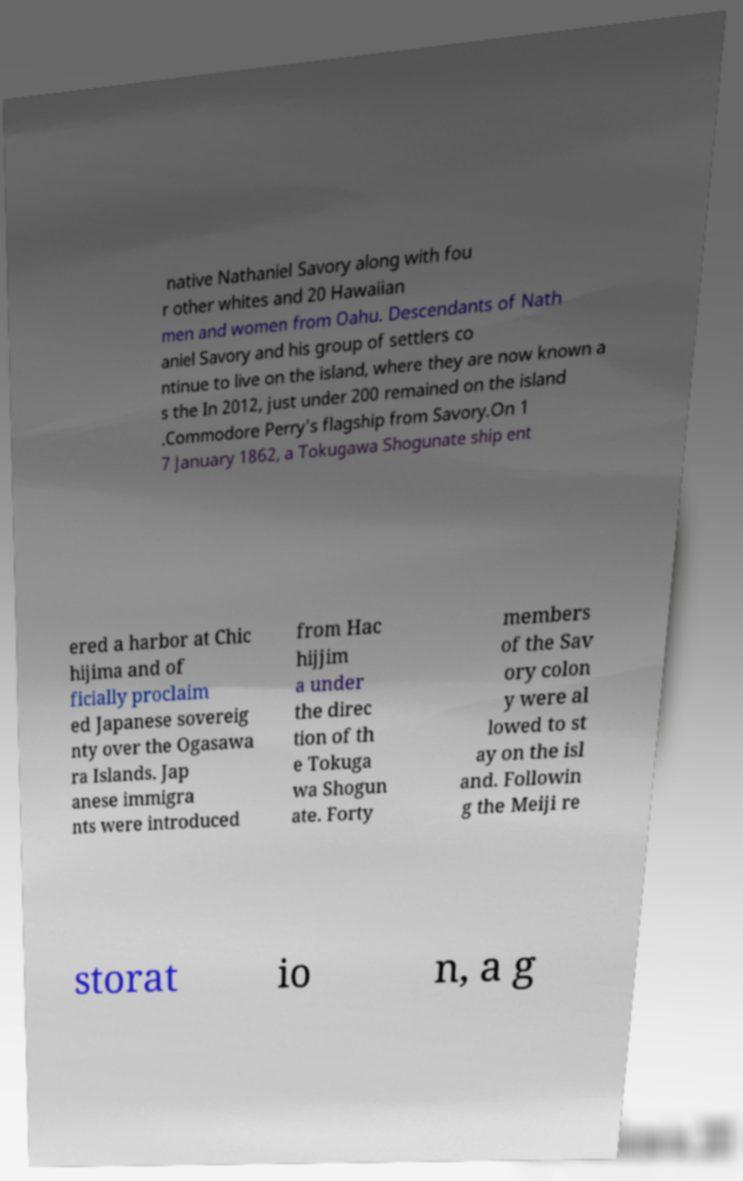For documentation purposes, I need the text within this image transcribed. Could you provide that? native Nathaniel Savory along with fou r other whites and 20 Hawaiian men and women from Oahu. Descendants of Nath aniel Savory and his group of settlers co ntinue to live on the island, where they are now known a s the In 2012, just under 200 remained on the island .Commodore Perry's flagship from Savory.On 1 7 January 1862, a Tokugawa Shogunate ship ent ered a harbor at Chic hijima and of ficially proclaim ed Japanese sovereig nty over the Ogasawa ra Islands. Jap anese immigra nts were introduced from Hac hijjim a under the direc tion of th e Tokuga wa Shogun ate. Forty members of the Sav ory colon y were al lowed to st ay on the isl and. Followin g the Meiji re storat io n, a g 